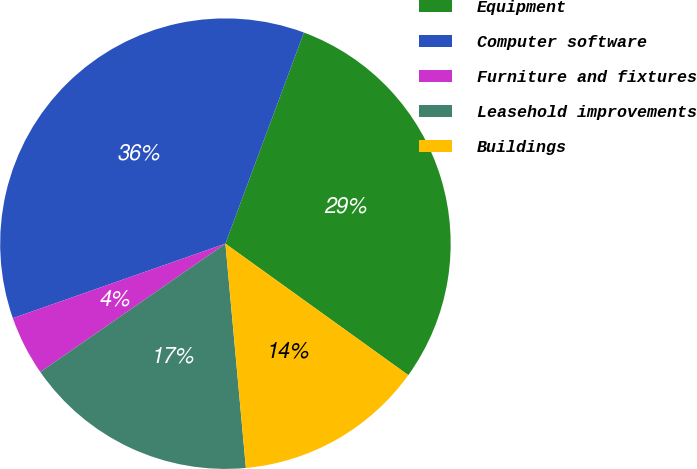Convert chart to OTSL. <chart><loc_0><loc_0><loc_500><loc_500><pie_chart><fcel>Equipment<fcel>Computer software<fcel>Furniture and fixtures<fcel>Leasehold improvements<fcel>Buildings<nl><fcel>29.25%<fcel>36.03%<fcel>4.28%<fcel>16.8%<fcel>13.63%<nl></chart> 